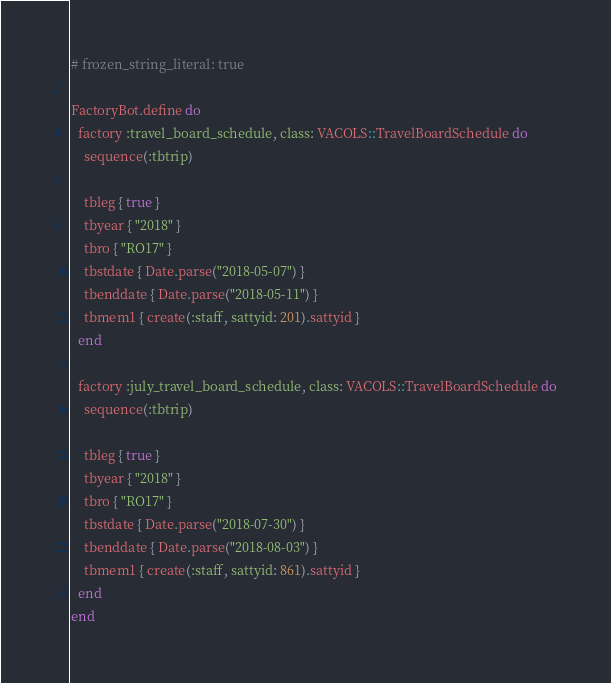<code> <loc_0><loc_0><loc_500><loc_500><_Ruby_># frozen_string_literal: true

FactoryBot.define do
  factory :travel_board_schedule, class: VACOLS::TravelBoardSchedule do
    sequence(:tbtrip)

    tbleg { true }
    tbyear { "2018" }
    tbro { "RO17" }
    tbstdate { Date.parse("2018-05-07") }
    tbenddate { Date.parse("2018-05-11") }
    tbmem1 { create(:staff, sattyid: 201).sattyid }
  end

  factory :july_travel_board_schedule, class: VACOLS::TravelBoardSchedule do
    sequence(:tbtrip)

    tbleg { true }
    tbyear { "2018" }
    tbro { "RO17" }
    tbstdate { Date.parse("2018-07-30") }
    tbenddate { Date.parse("2018-08-03") }
    tbmem1 { create(:staff, sattyid: 861).sattyid }
  end
end
</code> 